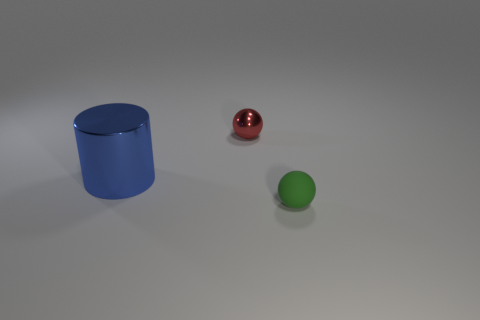Are there any other things that have the same material as the green sphere?
Keep it short and to the point. No. Is there any other thing that is the same shape as the blue object?
Provide a short and direct response. No. There is another object that is the same material as the red thing; what size is it?
Keep it short and to the point. Large. How many small objects are blue cylinders or yellow matte cylinders?
Keep it short and to the point. 0. Is there a small red object made of the same material as the cylinder?
Your response must be concise. Yes. There is a sphere in front of the blue metallic cylinder; what material is it?
Give a very brief answer. Rubber. There is another sphere that is the same size as the metal sphere; what is its color?
Give a very brief answer. Green. What number of other objects are the same shape as the small green matte thing?
Provide a succinct answer. 1. There is a sphere left of the green rubber object; what size is it?
Provide a succinct answer. Small. How many tiny metal spheres are on the left side of the small thing left of the rubber sphere?
Your answer should be compact. 0. 